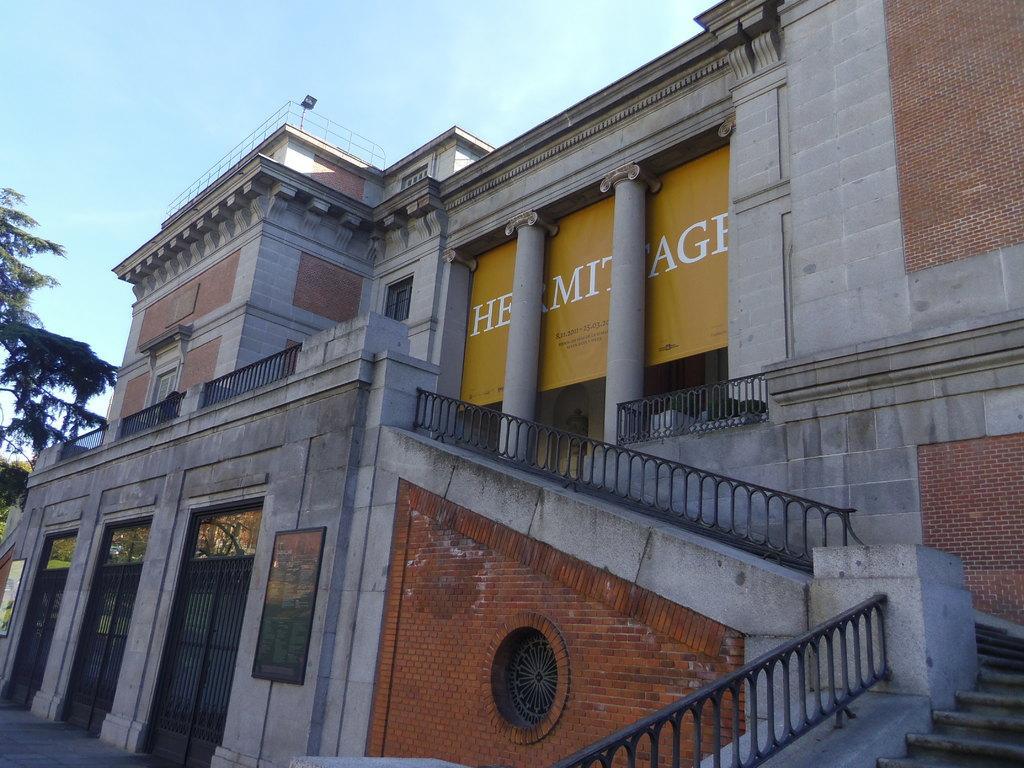Could you give a brief overview of what you see in this image? In this image we can see building which has stairs, gate, stone pillars there is wording and in the background of the image there are some trees and top of the image there is clear sky. 